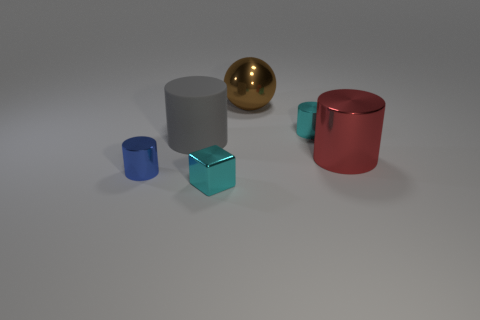Subtract all large shiny cylinders. How many cylinders are left? 3 Add 3 brown things. How many objects exist? 9 Subtract all red cylinders. How many cylinders are left? 3 Subtract all cubes. How many objects are left? 5 Subtract all cyan blocks. How many cyan cylinders are left? 1 Subtract all brown blocks. Subtract all small cyan things. How many objects are left? 4 Add 3 tiny cyan shiny objects. How many tiny cyan shiny objects are left? 5 Add 6 purple metallic blocks. How many purple metallic blocks exist? 6 Subtract 0 yellow cylinders. How many objects are left? 6 Subtract 1 cylinders. How many cylinders are left? 3 